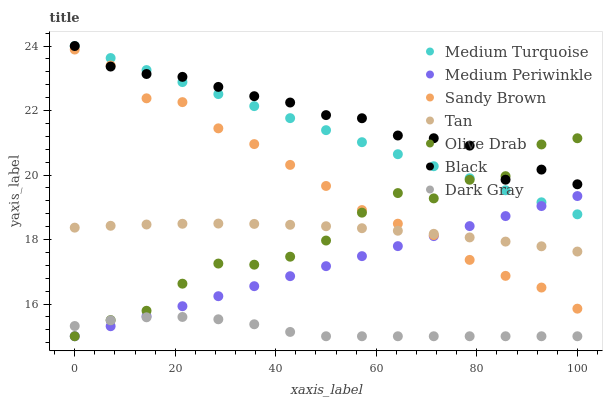Does Dark Gray have the minimum area under the curve?
Answer yes or no. Yes. Does Black have the maximum area under the curve?
Answer yes or no. Yes. Does Black have the minimum area under the curve?
Answer yes or no. No. Does Dark Gray have the maximum area under the curve?
Answer yes or no. No. Is Medium Turquoise the smoothest?
Answer yes or no. Yes. Is Olive Drab the roughest?
Answer yes or no. Yes. Is Dark Gray the smoothest?
Answer yes or no. No. Is Dark Gray the roughest?
Answer yes or no. No. Does Medium Periwinkle have the lowest value?
Answer yes or no. Yes. Does Black have the lowest value?
Answer yes or no. No. Does Medium Turquoise have the highest value?
Answer yes or no. Yes. Does Dark Gray have the highest value?
Answer yes or no. No. Is Medium Periwinkle less than Black?
Answer yes or no. Yes. Is Sandy Brown greater than Dark Gray?
Answer yes or no. Yes. Does Sandy Brown intersect Medium Periwinkle?
Answer yes or no. Yes. Is Sandy Brown less than Medium Periwinkle?
Answer yes or no. No. Is Sandy Brown greater than Medium Periwinkle?
Answer yes or no. No. Does Medium Periwinkle intersect Black?
Answer yes or no. No. 